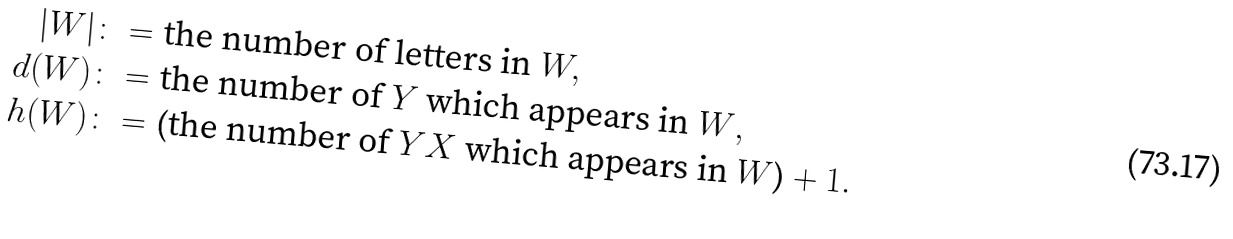<formula> <loc_0><loc_0><loc_500><loc_500>| W | & \colon = \text {the number of letters in } W , \\ d ( W ) & \colon = \text {the number of $Y$ which appears in $W$} , \\ h ( W ) & \colon = \text {(the number of $YX$ which appears in $W$)} + 1 .</formula> 